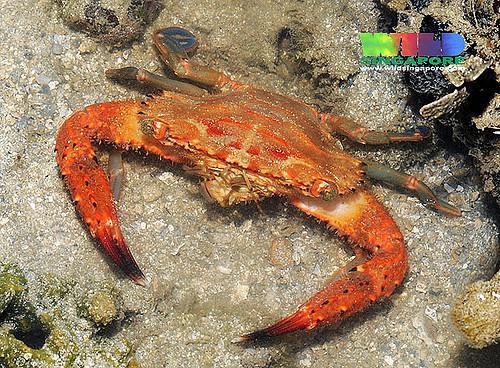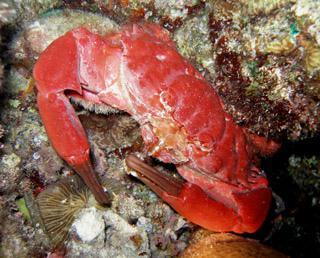The first image is the image on the left, the second image is the image on the right. Examine the images to the left and right. Is the description "Each image shows a crab with its face toward the front instead of rear-facing, and all crabs are angled leftward." accurate? Answer yes or no. Yes. The first image is the image on the left, the second image is the image on the right. For the images displayed, is the sentence "All of the crabs have their front limbs extended and their claws open wide." factually correct? Answer yes or no. No. 